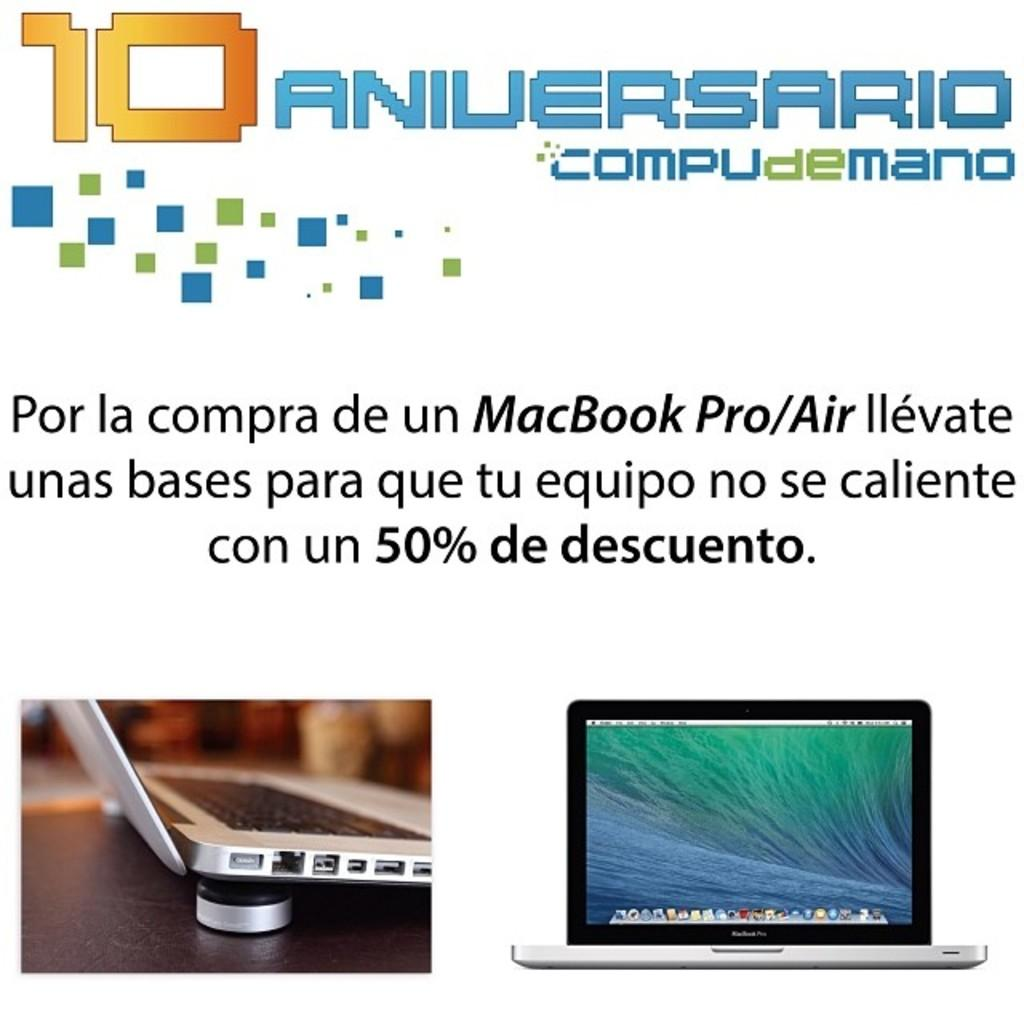<image>
Give a short and clear explanation of the subsequent image. A sign that says 10 Aniversario Compudemano shows two Apple laptops. 